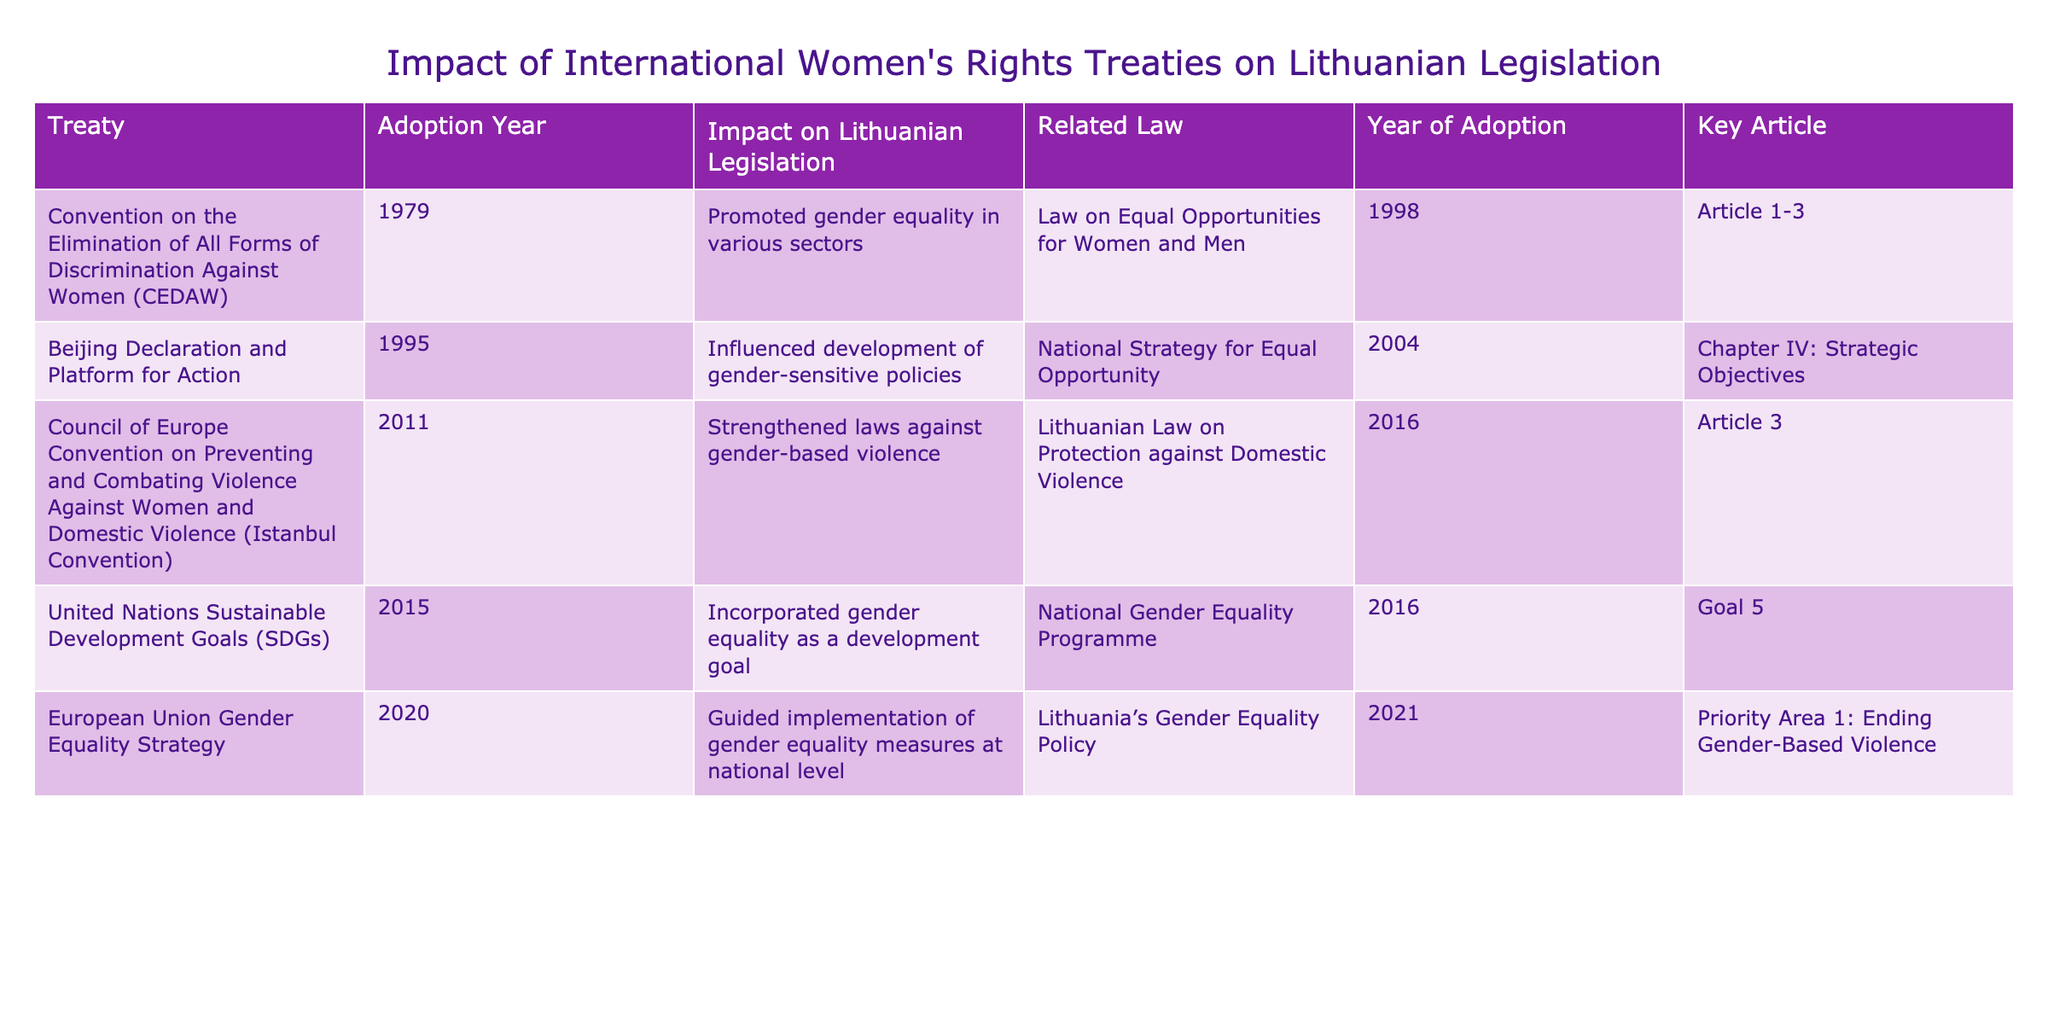What year was the CEDAW adopted? The table specifies the adoption year of CEDAW as 1979 in the corresponding column.
Answer: 1979 Which law was adopted in Lithuania in 2004 as a result of the Beijing Declaration? According to the table, the related law in Lithuania adopted in 2004 is the National Strategy for Equal Opportunity.
Answer: National Strategy for Equal Opportunity Did the Istanbul Convention influence the Lithuanian Law on Protection against Domestic Violence? The table shows that the Istanbul Convention strengthened laws against gender-based violence, which includes the Lithuanian Law on Protection against Domestic Violence, indicating a positive influence.
Answer: Yes What is the key article of the Lithuanian Law on Protection against Domestic Violence? The table outlines the related law and specifies that the key article is Article 3.
Answer: Article 3 How many treaties were adopted in the years 2000 and later? The table lists five treaties, and the ones adopted in 2000 or later are the Istanbul Convention (2011), SDGs (2015), and the EU Gender Equality Strategy (2020), totaling three treaties.
Answer: 3 What was the impact of the SDGs on Lithuanian legislation? The table indicates that the SDGs incorporated gender equality as a development goal, directly relating to the National Gender Equality Programme adopted in 2016.
Answer: Incorporated gender equality as a development goal Which treaty influenced the development of gender-sensitive policies and what was its impact on legislation? The table shows that the Beijing Declaration influenced the development of gender-sensitive policies, leading to the adoption of the National Strategy for Equal Opportunity in 2004.
Answer: Influenced development of gender-sensitive policies How many key articles are mentioned in the table that relate to Lithuanian laws? By reviewing each treaty's key article listed, the total count is seven key articles corresponding to the five treaties.
Answer: 7 Which treaty directly mentions the issue of gender-based violence? The table highlights that the Istanbul Convention directly discusses gender-based violence, as indicated in its impact statement.
Answer: Istanbul Convention What is the priority area linked to the EU Gender Equality Strategy? The table states that the priority area linked to the EU Gender Equality Strategy is "Ending Gender-Based Violence."
Answer: Ending Gender-Based Violence What is the relationship between the CEDAW and the law on Equal Opportunities for Women and Men? The table reveals that the CEDAW promoted gender equality in various sectors, which is directly tied to the adoption of the law on Equal Opportunities for Women and Men.
Answer: Promoted gender equality in various sectors 